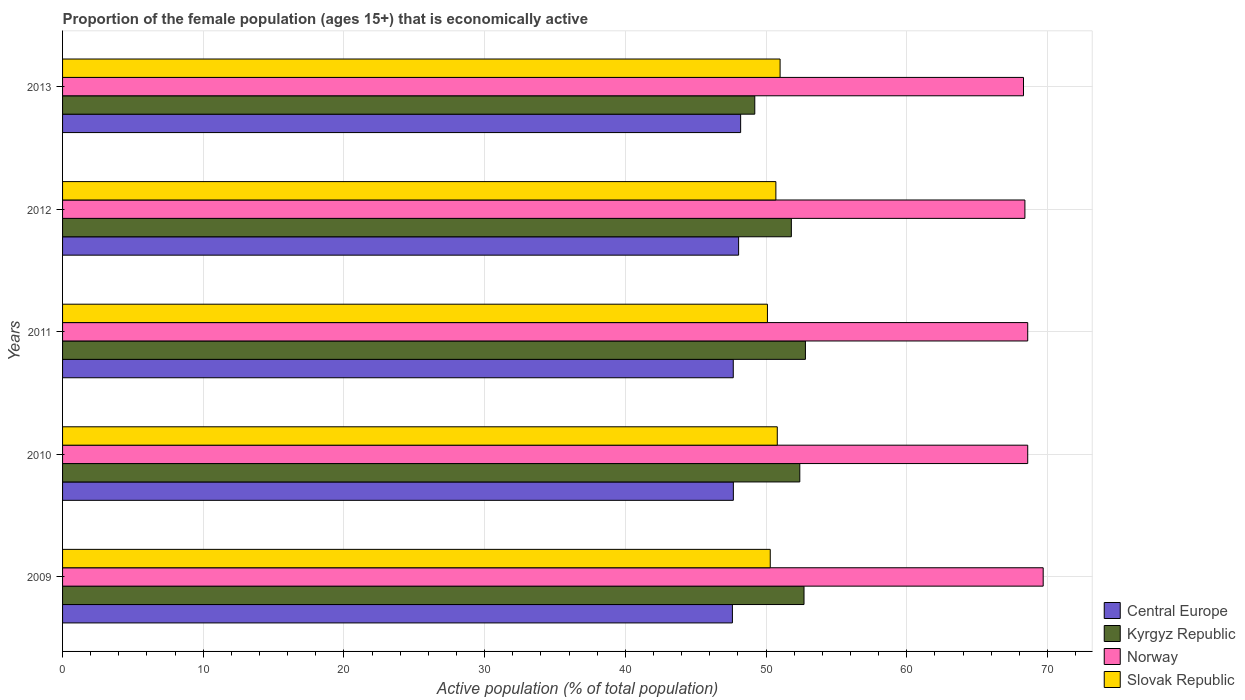What is the label of the 5th group of bars from the top?
Offer a very short reply. 2009. In how many cases, is the number of bars for a given year not equal to the number of legend labels?
Your answer should be compact. 0. What is the proportion of the female population that is economically active in Central Europe in 2009?
Ensure brevity in your answer.  47.61. Across all years, what is the maximum proportion of the female population that is economically active in Central Europe?
Provide a short and direct response. 48.2. Across all years, what is the minimum proportion of the female population that is economically active in Central Europe?
Ensure brevity in your answer.  47.61. What is the total proportion of the female population that is economically active in Norway in the graph?
Offer a very short reply. 343.6. What is the difference between the proportion of the female population that is economically active in Norway in 2011 and that in 2013?
Offer a terse response. 0.3. What is the difference between the proportion of the female population that is economically active in Norway in 2009 and the proportion of the female population that is economically active in Slovak Republic in 2012?
Offer a very short reply. 19. What is the average proportion of the female population that is economically active in Slovak Republic per year?
Ensure brevity in your answer.  50.58. In the year 2012, what is the difference between the proportion of the female population that is economically active in Norway and proportion of the female population that is economically active in Slovak Republic?
Provide a succinct answer. 17.7. What is the ratio of the proportion of the female population that is economically active in Kyrgyz Republic in 2009 to that in 2012?
Your answer should be very brief. 1.02. Is the proportion of the female population that is economically active in Kyrgyz Republic in 2009 less than that in 2011?
Keep it short and to the point. Yes. What is the difference between the highest and the second highest proportion of the female population that is economically active in Central Europe?
Your response must be concise. 0.14. What is the difference between the highest and the lowest proportion of the female population that is economically active in Central Europe?
Provide a succinct answer. 0.59. Is the sum of the proportion of the female population that is economically active in Central Europe in 2009 and 2013 greater than the maximum proportion of the female population that is economically active in Kyrgyz Republic across all years?
Offer a terse response. Yes. What does the 4th bar from the top in 2011 represents?
Offer a very short reply. Central Europe. What does the 3rd bar from the bottom in 2010 represents?
Ensure brevity in your answer.  Norway. Are the values on the major ticks of X-axis written in scientific E-notation?
Give a very brief answer. No. Does the graph contain any zero values?
Your answer should be compact. No. What is the title of the graph?
Your answer should be compact. Proportion of the female population (ages 15+) that is economically active. What is the label or title of the X-axis?
Your response must be concise. Active population (% of total population). What is the Active population (% of total population) of Central Europe in 2009?
Offer a very short reply. 47.61. What is the Active population (% of total population) of Kyrgyz Republic in 2009?
Make the answer very short. 52.7. What is the Active population (% of total population) of Norway in 2009?
Provide a short and direct response. 69.7. What is the Active population (% of total population) in Slovak Republic in 2009?
Your answer should be very brief. 50.3. What is the Active population (% of total population) of Central Europe in 2010?
Keep it short and to the point. 47.68. What is the Active population (% of total population) of Kyrgyz Republic in 2010?
Offer a terse response. 52.4. What is the Active population (% of total population) of Norway in 2010?
Your answer should be compact. 68.6. What is the Active population (% of total population) of Slovak Republic in 2010?
Offer a terse response. 50.8. What is the Active population (% of total population) in Central Europe in 2011?
Your response must be concise. 47.67. What is the Active population (% of total population) of Kyrgyz Republic in 2011?
Your answer should be very brief. 52.8. What is the Active population (% of total population) of Norway in 2011?
Provide a short and direct response. 68.6. What is the Active population (% of total population) of Slovak Republic in 2011?
Keep it short and to the point. 50.1. What is the Active population (% of total population) in Central Europe in 2012?
Keep it short and to the point. 48.05. What is the Active population (% of total population) in Kyrgyz Republic in 2012?
Give a very brief answer. 51.8. What is the Active population (% of total population) of Norway in 2012?
Keep it short and to the point. 68.4. What is the Active population (% of total population) in Slovak Republic in 2012?
Your response must be concise. 50.7. What is the Active population (% of total population) of Central Europe in 2013?
Offer a terse response. 48.2. What is the Active population (% of total population) in Kyrgyz Republic in 2013?
Offer a terse response. 49.2. What is the Active population (% of total population) in Norway in 2013?
Your response must be concise. 68.3. Across all years, what is the maximum Active population (% of total population) of Central Europe?
Provide a short and direct response. 48.2. Across all years, what is the maximum Active population (% of total population) of Kyrgyz Republic?
Provide a short and direct response. 52.8. Across all years, what is the maximum Active population (% of total population) of Norway?
Your answer should be very brief. 69.7. Across all years, what is the maximum Active population (% of total population) in Slovak Republic?
Keep it short and to the point. 51. Across all years, what is the minimum Active population (% of total population) in Central Europe?
Your answer should be compact. 47.61. Across all years, what is the minimum Active population (% of total population) of Kyrgyz Republic?
Provide a succinct answer. 49.2. Across all years, what is the minimum Active population (% of total population) in Norway?
Your answer should be compact. 68.3. Across all years, what is the minimum Active population (% of total population) of Slovak Republic?
Offer a terse response. 50.1. What is the total Active population (% of total population) of Central Europe in the graph?
Give a very brief answer. 239.21. What is the total Active population (% of total population) in Kyrgyz Republic in the graph?
Keep it short and to the point. 258.9. What is the total Active population (% of total population) of Norway in the graph?
Your answer should be compact. 343.6. What is the total Active population (% of total population) of Slovak Republic in the graph?
Offer a very short reply. 252.9. What is the difference between the Active population (% of total population) in Central Europe in 2009 and that in 2010?
Your answer should be very brief. -0.07. What is the difference between the Active population (% of total population) in Kyrgyz Republic in 2009 and that in 2010?
Your answer should be compact. 0.3. What is the difference between the Active population (% of total population) of Norway in 2009 and that in 2010?
Your answer should be very brief. 1.1. What is the difference between the Active population (% of total population) of Slovak Republic in 2009 and that in 2010?
Provide a succinct answer. -0.5. What is the difference between the Active population (% of total population) in Central Europe in 2009 and that in 2011?
Make the answer very short. -0.06. What is the difference between the Active population (% of total population) of Central Europe in 2009 and that in 2012?
Provide a short and direct response. -0.44. What is the difference between the Active population (% of total population) of Kyrgyz Republic in 2009 and that in 2012?
Your answer should be very brief. 0.9. What is the difference between the Active population (% of total population) of Central Europe in 2009 and that in 2013?
Your answer should be very brief. -0.59. What is the difference between the Active population (% of total population) of Slovak Republic in 2009 and that in 2013?
Your response must be concise. -0.7. What is the difference between the Active population (% of total population) in Central Europe in 2010 and that in 2011?
Offer a very short reply. 0.01. What is the difference between the Active population (% of total population) in Norway in 2010 and that in 2011?
Provide a short and direct response. 0. What is the difference between the Active population (% of total population) in Central Europe in 2010 and that in 2012?
Offer a very short reply. -0.37. What is the difference between the Active population (% of total population) in Central Europe in 2010 and that in 2013?
Make the answer very short. -0.52. What is the difference between the Active population (% of total population) of Kyrgyz Republic in 2010 and that in 2013?
Offer a terse response. 3.2. What is the difference between the Active population (% of total population) of Norway in 2010 and that in 2013?
Your answer should be very brief. 0.3. What is the difference between the Active population (% of total population) in Central Europe in 2011 and that in 2012?
Ensure brevity in your answer.  -0.38. What is the difference between the Active population (% of total population) of Central Europe in 2011 and that in 2013?
Offer a very short reply. -0.52. What is the difference between the Active population (% of total population) of Kyrgyz Republic in 2011 and that in 2013?
Provide a short and direct response. 3.6. What is the difference between the Active population (% of total population) of Central Europe in 2012 and that in 2013?
Make the answer very short. -0.14. What is the difference between the Active population (% of total population) in Norway in 2012 and that in 2013?
Offer a very short reply. 0.1. What is the difference between the Active population (% of total population) of Central Europe in 2009 and the Active population (% of total population) of Kyrgyz Republic in 2010?
Your answer should be very brief. -4.79. What is the difference between the Active population (% of total population) of Central Europe in 2009 and the Active population (% of total population) of Norway in 2010?
Keep it short and to the point. -20.99. What is the difference between the Active population (% of total population) in Central Europe in 2009 and the Active population (% of total population) in Slovak Republic in 2010?
Ensure brevity in your answer.  -3.19. What is the difference between the Active population (% of total population) of Kyrgyz Republic in 2009 and the Active population (% of total population) of Norway in 2010?
Make the answer very short. -15.9. What is the difference between the Active population (% of total population) in Kyrgyz Republic in 2009 and the Active population (% of total population) in Slovak Republic in 2010?
Make the answer very short. 1.9. What is the difference between the Active population (% of total population) in Norway in 2009 and the Active population (% of total population) in Slovak Republic in 2010?
Provide a short and direct response. 18.9. What is the difference between the Active population (% of total population) of Central Europe in 2009 and the Active population (% of total population) of Kyrgyz Republic in 2011?
Offer a very short reply. -5.19. What is the difference between the Active population (% of total population) of Central Europe in 2009 and the Active population (% of total population) of Norway in 2011?
Provide a short and direct response. -20.99. What is the difference between the Active population (% of total population) in Central Europe in 2009 and the Active population (% of total population) in Slovak Republic in 2011?
Your answer should be very brief. -2.49. What is the difference between the Active population (% of total population) in Kyrgyz Republic in 2009 and the Active population (% of total population) in Norway in 2011?
Ensure brevity in your answer.  -15.9. What is the difference between the Active population (% of total population) in Norway in 2009 and the Active population (% of total population) in Slovak Republic in 2011?
Your response must be concise. 19.6. What is the difference between the Active population (% of total population) of Central Europe in 2009 and the Active population (% of total population) of Kyrgyz Republic in 2012?
Your answer should be compact. -4.19. What is the difference between the Active population (% of total population) of Central Europe in 2009 and the Active population (% of total population) of Norway in 2012?
Keep it short and to the point. -20.79. What is the difference between the Active population (% of total population) in Central Europe in 2009 and the Active population (% of total population) in Slovak Republic in 2012?
Give a very brief answer. -3.09. What is the difference between the Active population (% of total population) of Kyrgyz Republic in 2009 and the Active population (% of total population) of Norway in 2012?
Your answer should be compact. -15.7. What is the difference between the Active population (% of total population) of Norway in 2009 and the Active population (% of total population) of Slovak Republic in 2012?
Your answer should be compact. 19. What is the difference between the Active population (% of total population) of Central Europe in 2009 and the Active population (% of total population) of Kyrgyz Republic in 2013?
Your response must be concise. -1.59. What is the difference between the Active population (% of total population) in Central Europe in 2009 and the Active population (% of total population) in Norway in 2013?
Your answer should be compact. -20.69. What is the difference between the Active population (% of total population) of Central Europe in 2009 and the Active population (% of total population) of Slovak Republic in 2013?
Provide a succinct answer. -3.39. What is the difference between the Active population (% of total population) of Kyrgyz Republic in 2009 and the Active population (% of total population) of Norway in 2013?
Keep it short and to the point. -15.6. What is the difference between the Active population (% of total population) of Kyrgyz Republic in 2009 and the Active population (% of total population) of Slovak Republic in 2013?
Provide a succinct answer. 1.7. What is the difference between the Active population (% of total population) in Central Europe in 2010 and the Active population (% of total population) in Kyrgyz Republic in 2011?
Keep it short and to the point. -5.12. What is the difference between the Active population (% of total population) in Central Europe in 2010 and the Active population (% of total population) in Norway in 2011?
Offer a terse response. -20.92. What is the difference between the Active population (% of total population) in Central Europe in 2010 and the Active population (% of total population) in Slovak Republic in 2011?
Give a very brief answer. -2.42. What is the difference between the Active population (% of total population) of Kyrgyz Republic in 2010 and the Active population (% of total population) of Norway in 2011?
Give a very brief answer. -16.2. What is the difference between the Active population (% of total population) in Central Europe in 2010 and the Active population (% of total population) in Kyrgyz Republic in 2012?
Provide a succinct answer. -4.12. What is the difference between the Active population (% of total population) in Central Europe in 2010 and the Active population (% of total population) in Norway in 2012?
Offer a very short reply. -20.72. What is the difference between the Active population (% of total population) in Central Europe in 2010 and the Active population (% of total population) in Slovak Republic in 2012?
Give a very brief answer. -3.02. What is the difference between the Active population (% of total population) in Kyrgyz Republic in 2010 and the Active population (% of total population) in Slovak Republic in 2012?
Give a very brief answer. 1.7. What is the difference between the Active population (% of total population) in Norway in 2010 and the Active population (% of total population) in Slovak Republic in 2012?
Your answer should be very brief. 17.9. What is the difference between the Active population (% of total population) of Central Europe in 2010 and the Active population (% of total population) of Kyrgyz Republic in 2013?
Your answer should be compact. -1.52. What is the difference between the Active population (% of total population) in Central Europe in 2010 and the Active population (% of total population) in Norway in 2013?
Provide a succinct answer. -20.62. What is the difference between the Active population (% of total population) in Central Europe in 2010 and the Active population (% of total population) in Slovak Republic in 2013?
Offer a terse response. -3.32. What is the difference between the Active population (% of total population) of Kyrgyz Republic in 2010 and the Active population (% of total population) of Norway in 2013?
Give a very brief answer. -15.9. What is the difference between the Active population (% of total population) of Kyrgyz Republic in 2010 and the Active population (% of total population) of Slovak Republic in 2013?
Your answer should be very brief. 1.4. What is the difference between the Active population (% of total population) in Central Europe in 2011 and the Active population (% of total population) in Kyrgyz Republic in 2012?
Make the answer very short. -4.13. What is the difference between the Active population (% of total population) in Central Europe in 2011 and the Active population (% of total population) in Norway in 2012?
Offer a very short reply. -20.73. What is the difference between the Active population (% of total population) of Central Europe in 2011 and the Active population (% of total population) of Slovak Republic in 2012?
Your response must be concise. -3.03. What is the difference between the Active population (% of total population) of Kyrgyz Republic in 2011 and the Active population (% of total population) of Norway in 2012?
Offer a terse response. -15.6. What is the difference between the Active population (% of total population) of Central Europe in 2011 and the Active population (% of total population) of Kyrgyz Republic in 2013?
Give a very brief answer. -1.53. What is the difference between the Active population (% of total population) of Central Europe in 2011 and the Active population (% of total population) of Norway in 2013?
Ensure brevity in your answer.  -20.63. What is the difference between the Active population (% of total population) of Central Europe in 2011 and the Active population (% of total population) of Slovak Republic in 2013?
Ensure brevity in your answer.  -3.33. What is the difference between the Active population (% of total population) in Kyrgyz Republic in 2011 and the Active population (% of total population) in Norway in 2013?
Your response must be concise. -15.5. What is the difference between the Active population (% of total population) in Kyrgyz Republic in 2011 and the Active population (% of total population) in Slovak Republic in 2013?
Provide a succinct answer. 1.8. What is the difference between the Active population (% of total population) in Norway in 2011 and the Active population (% of total population) in Slovak Republic in 2013?
Your answer should be very brief. 17.6. What is the difference between the Active population (% of total population) in Central Europe in 2012 and the Active population (% of total population) in Kyrgyz Republic in 2013?
Your answer should be very brief. -1.15. What is the difference between the Active population (% of total population) of Central Europe in 2012 and the Active population (% of total population) of Norway in 2013?
Offer a terse response. -20.25. What is the difference between the Active population (% of total population) of Central Europe in 2012 and the Active population (% of total population) of Slovak Republic in 2013?
Offer a terse response. -2.95. What is the difference between the Active population (% of total population) in Kyrgyz Republic in 2012 and the Active population (% of total population) in Norway in 2013?
Ensure brevity in your answer.  -16.5. What is the average Active population (% of total population) of Central Europe per year?
Keep it short and to the point. 47.84. What is the average Active population (% of total population) of Kyrgyz Republic per year?
Offer a very short reply. 51.78. What is the average Active population (% of total population) in Norway per year?
Keep it short and to the point. 68.72. What is the average Active population (% of total population) of Slovak Republic per year?
Your answer should be very brief. 50.58. In the year 2009, what is the difference between the Active population (% of total population) in Central Europe and Active population (% of total population) in Kyrgyz Republic?
Make the answer very short. -5.09. In the year 2009, what is the difference between the Active population (% of total population) of Central Europe and Active population (% of total population) of Norway?
Make the answer very short. -22.09. In the year 2009, what is the difference between the Active population (% of total population) of Central Europe and Active population (% of total population) of Slovak Republic?
Give a very brief answer. -2.69. In the year 2009, what is the difference between the Active population (% of total population) of Kyrgyz Republic and Active population (% of total population) of Norway?
Give a very brief answer. -17. In the year 2009, what is the difference between the Active population (% of total population) of Norway and Active population (% of total population) of Slovak Republic?
Your response must be concise. 19.4. In the year 2010, what is the difference between the Active population (% of total population) of Central Europe and Active population (% of total population) of Kyrgyz Republic?
Your response must be concise. -4.72. In the year 2010, what is the difference between the Active population (% of total population) in Central Europe and Active population (% of total population) in Norway?
Your answer should be compact. -20.92. In the year 2010, what is the difference between the Active population (% of total population) of Central Europe and Active population (% of total population) of Slovak Republic?
Your answer should be compact. -3.12. In the year 2010, what is the difference between the Active population (% of total population) of Kyrgyz Republic and Active population (% of total population) of Norway?
Your answer should be compact. -16.2. In the year 2010, what is the difference between the Active population (% of total population) in Kyrgyz Republic and Active population (% of total population) in Slovak Republic?
Keep it short and to the point. 1.6. In the year 2011, what is the difference between the Active population (% of total population) of Central Europe and Active population (% of total population) of Kyrgyz Republic?
Provide a succinct answer. -5.13. In the year 2011, what is the difference between the Active population (% of total population) in Central Europe and Active population (% of total population) in Norway?
Give a very brief answer. -20.93. In the year 2011, what is the difference between the Active population (% of total population) of Central Europe and Active population (% of total population) of Slovak Republic?
Your response must be concise. -2.43. In the year 2011, what is the difference between the Active population (% of total population) in Kyrgyz Republic and Active population (% of total population) in Norway?
Ensure brevity in your answer.  -15.8. In the year 2011, what is the difference between the Active population (% of total population) in Kyrgyz Republic and Active population (% of total population) in Slovak Republic?
Offer a terse response. 2.7. In the year 2011, what is the difference between the Active population (% of total population) of Norway and Active population (% of total population) of Slovak Republic?
Offer a very short reply. 18.5. In the year 2012, what is the difference between the Active population (% of total population) in Central Europe and Active population (% of total population) in Kyrgyz Republic?
Your answer should be very brief. -3.75. In the year 2012, what is the difference between the Active population (% of total population) of Central Europe and Active population (% of total population) of Norway?
Your answer should be very brief. -20.35. In the year 2012, what is the difference between the Active population (% of total population) in Central Europe and Active population (% of total population) in Slovak Republic?
Offer a terse response. -2.65. In the year 2012, what is the difference between the Active population (% of total population) of Kyrgyz Republic and Active population (% of total population) of Norway?
Offer a terse response. -16.6. In the year 2013, what is the difference between the Active population (% of total population) in Central Europe and Active population (% of total population) in Kyrgyz Republic?
Provide a succinct answer. -1. In the year 2013, what is the difference between the Active population (% of total population) in Central Europe and Active population (% of total population) in Norway?
Your answer should be very brief. -20.1. In the year 2013, what is the difference between the Active population (% of total population) in Central Europe and Active population (% of total population) in Slovak Republic?
Provide a succinct answer. -2.8. In the year 2013, what is the difference between the Active population (% of total population) of Kyrgyz Republic and Active population (% of total population) of Norway?
Give a very brief answer. -19.1. What is the ratio of the Active population (% of total population) of Central Europe in 2009 to that in 2010?
Make the answer very short. 1. What is the ratio of the Active population (% of total population) in Slovak Republic in 2009 to that in 2010?
Offer a terse response. 0.99. What is the ratio of the Active population (% of total population) of Kyrgyz Republic in 2009 to that in 2011?
Provide a succinct answer. 1. What is the ratio of the Active population (% of total population) of Central Europe in 2009 to that in 2012?
Your answer should be compact. 0.99. What is the ratio of the Active population (% of total population) in Kyrgyz Republic in 2009 to that in 2012?
Your response must be concise. 1.02. What is the ratio of the Active population (% of total population) of Central Europe in 2009 to that in 2013?
Your response must be concise. 0.99. What is the ratio of the Active population (% of total population) of Kyrgyz Republic in 2009 to that in 2013?
Offer a very short reply. 1.07. What is the ratio of the Active population (% of total population) of Norway in 2009 to that in 2013?
Provide a short and direct response. 1.02. What is the ratio of the Active population (% of total population) in Slovak Republic in 2009 to that in 2013?
Make the answer very short. 0.99. What is the ratio of the Active population (% of total population) of Kyrgyz Republic in 2010 to that in 2012?
Make the answer very short. 1.01. What is the ratio of the Active population (% of total population) in Central Europe in 2010 to that in 2013?
Your answer should be very brief. 0.99. What is the ratio of the Active population (% of total population) in Kyrgyz Republic in 2010 to that in 2013?
Ensure brevity in your answer.  1.06. What is the ratio of the Active population (% of total population) of Norway in 2010 to that in 2013?
Offer a very short reply. 1. What is the ratio of the Active population (% of total population) of Kyrgyz Republic in 2011 to that in 2012?
Keep it short and to the point. 1.02. What is the ratio of the Active population (% of total population) in Slovak Republic in 2011 to that in 2012?
Offer a very short reply. 0.99. What is the ratio of the Active population (% of total population) in Kyrgyz Republic in 2011 to that in 2013?
Your response must be concise. 1.07. What is the ratio of the Active population (% of total population) of Norway in 2011 to that in 2013?
Your answer should be compact. 1. What is the ratio of the Active population (% of total population) in Slovak Republic in 2011 to that in 2013?
Ensure brevity in your answer.  0.98. What is the ratio of the Active population (% of total population) in Kyrgyz Republic in 2012 to that in 2013?
Make the answer very short. 1.05. What is the difference between the highest and the second highest Active population (% of total population) in Central Europe?
Give a very brief answer. 0.14. What is the difference between the highest and the lowest Active population (% of total population) of Central Europe?
Provide a succinct answer. 0.59. What is the difference between the highest and the lowest Active population (% of total population) in Kyrgyz Republic?
Your response must be concise. 3.6. What is the difference between the highest and the lowest Active population (% of total population) of Norway?
Your answer should be very brief. 1.4. 